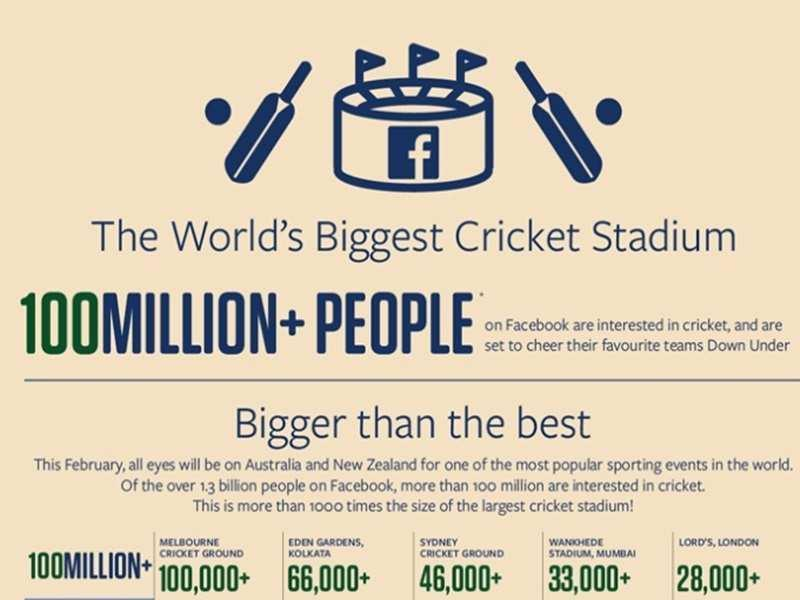WHat is the capacity of Eden Gardens, Kolkata
Answer the question with a short phrase. 66,000+ What is the capacity of Melbourne Cricket ground 100,000+ The total capacity of Wankhede Stadium and Lords is over how much 61000 What is the world's biggest cricket stadium facebook 